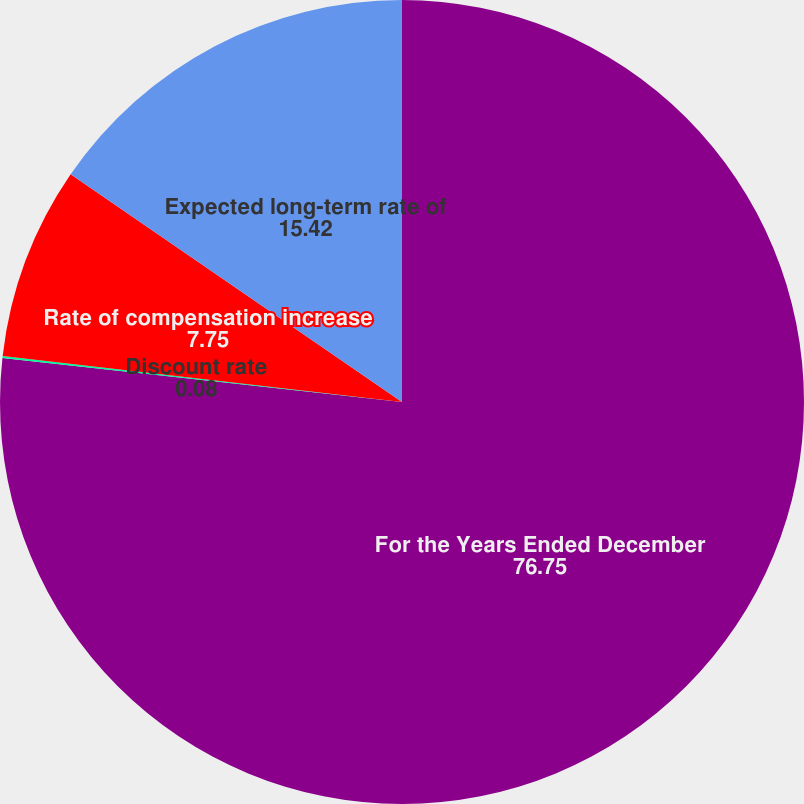<chart> <loc_0><loc_0><loc_500><loc_500><pie_chart><fcel>For the Years Ended December<fcel>Discount rate<fcel>Rate of compensation increase<fcel>Expected long-term rate of<nl><fcel>76.75%<fcel>0.08%<fcel>7.75%<fcel>15.42%<nl></chart> 